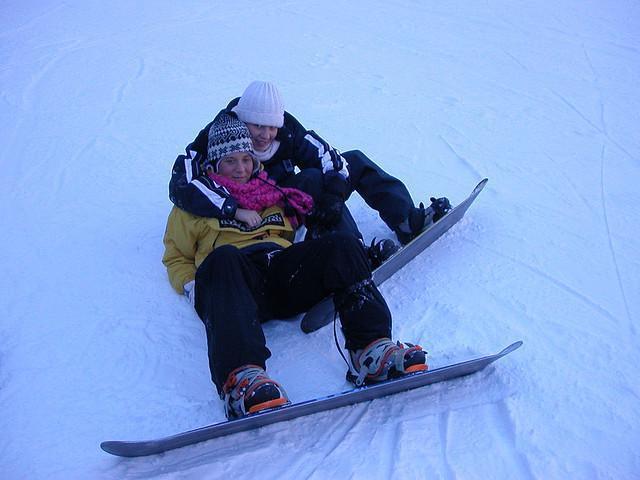How many snowboards are there?
Give a very brief answer. 2. How many people can you see?
Give a very brief answer. 2. 